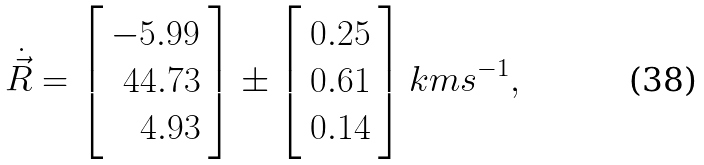<formula> <loc_0><loc_0><loc_500><loc_500>\dot { \vec { R } } = \left [ \begin{array} { r } - 5 . 9 9 \\ 4 4 . 7 3 \\ 4 . 9 3 \\ \end{array} \right ] \pm \left [ \begin{array} { r } 0 . 2 5 \\ 0 . 6 1 \\ 0 . 1 4 \\ \end{array} \right ] k m s ^ { - 1 } ,</formula> 